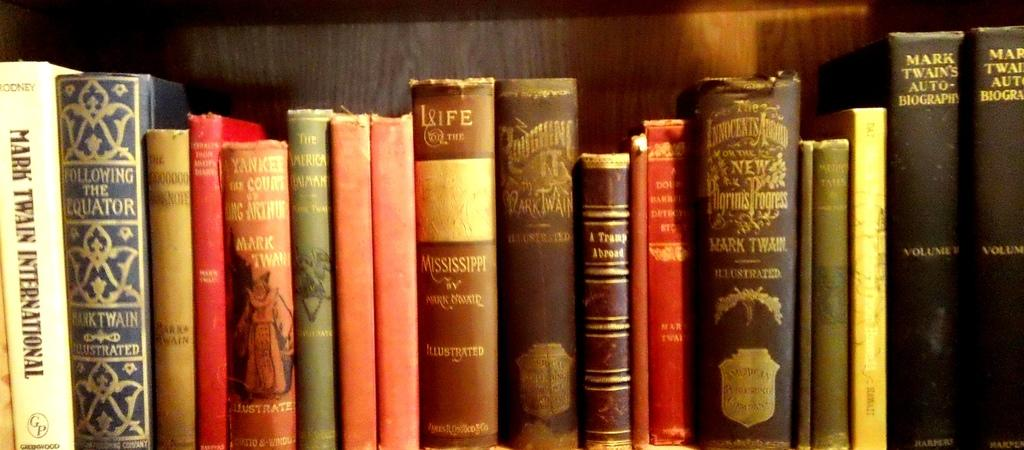Provide a one-sentence caption for the provided image. a Mark Twain book that is on a shelf. 